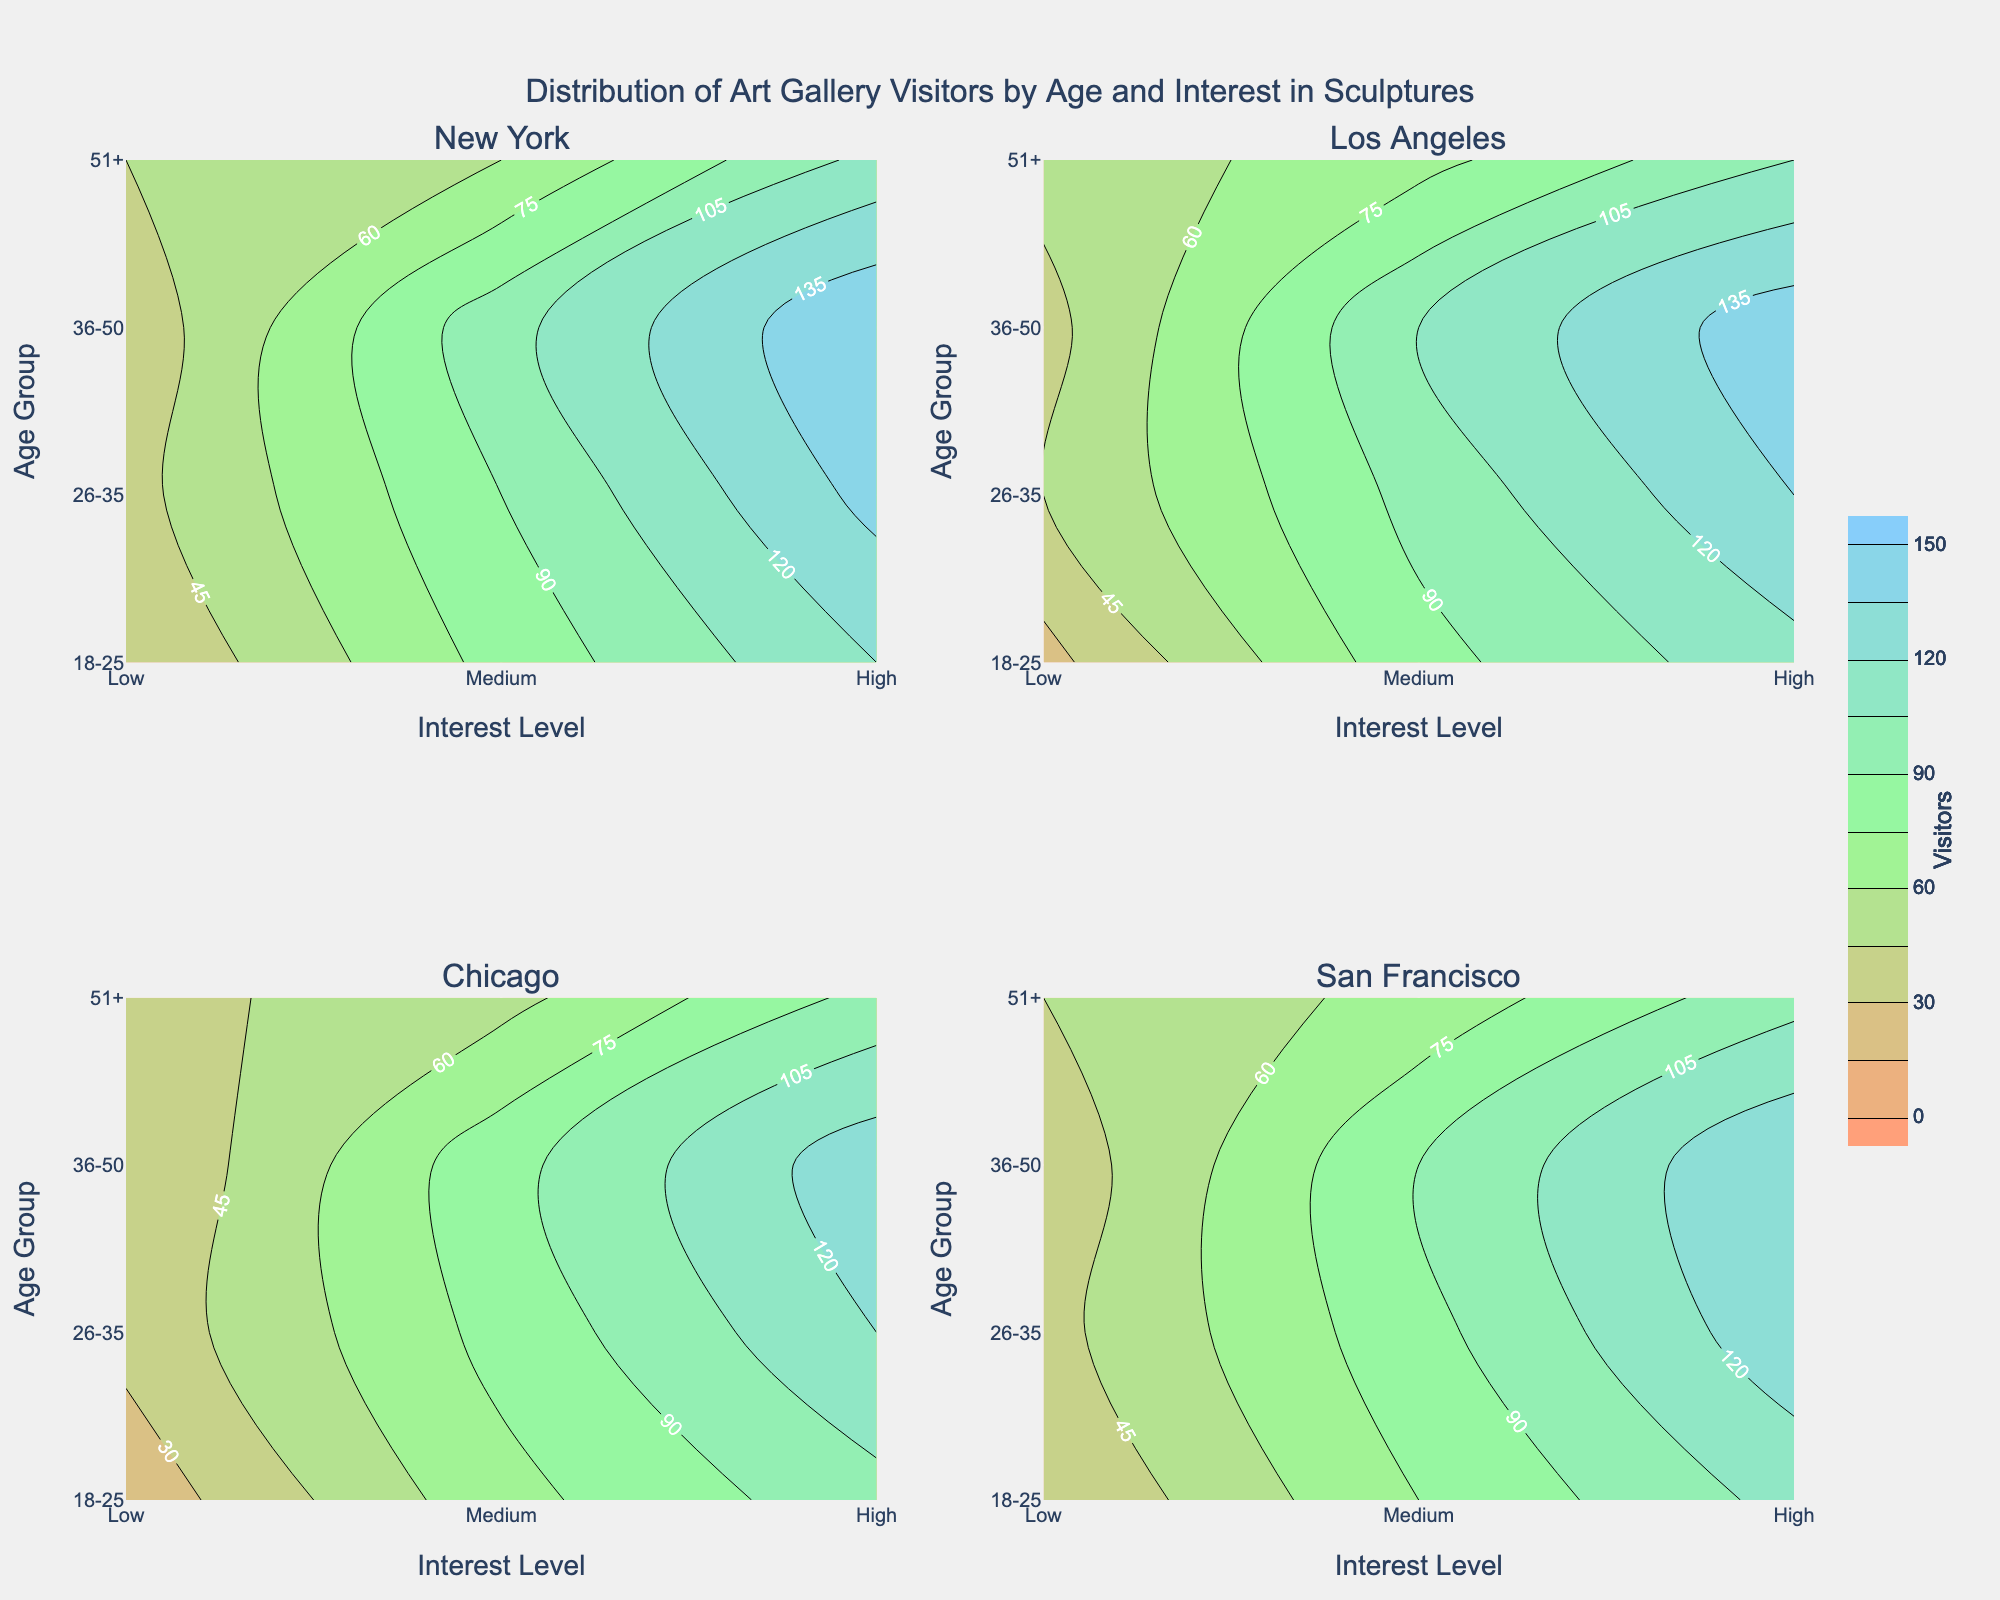Which age group in New York has the highest number of visitors with a high interest in sculptures? The contour plot for New York shows that the 36-50 age group has the highest number of visitors with a high interest level. The contour is at its highest peak in this age and interest group, marking 150 visitors.
Answer: 36-50 Which city has the lowest number of visitors with low interest in the 18-25 age group? The contour plot for Chicago shows the lowest number of visitors in the 18-25 age group with low interest in sculptures at 20 visitors, which is lower compared to other cities.
Answer: Chicago Compare the number of visitors aged 26-35 with a high interest in sculptures between New York and Los Angeles. Which city has more visitors? In New York, the contour plot indicates 140 visitors in the 26-35 age group with high interest, while Los Angeles shows 135 visitors in the same category. Therefore, New York has more visitors.
Answer: New York What is the general trend in the number of visitors with medium interest in sculptures across different age groups in San Francisco? The contour plot for San Francisco indicates an increasing trend in the number of visitors with medium interest in sculptures as age increases. For example, the visitor count starts from 75 in the 18-25 age group and increases to 90 in the 36-50 age group before decreasing slightly to 65 in the 51+ age group.
Answer: Increase then slight decrease with age In which city do visitors aged 51+ with a medium interest in sculptures have the highest count? Comparing the contour plots of all the cities, Los Angeles shows the highest number of visitors in the 51+ age group with a medium interest in sculptures at 70 visitors.
Answer: Los Angeles Find the age group in Chicago with the smallest difference in visitor numbers between medium and high interest levels. For the 36-50 age group in Chicago, the contour plot shows 85 visitors with medium interest and 130 visitors with high interest, giving a difference of 45, which is smaller compared to other age groups.
Answer: 36-50 Describe how the contour plot for visitors with high interest in sculptures compares between New York and San Francisco for the 36-50 age group. In both New York and San Francisco, the contour plot peaks for the 36-50 age group with a high interest in sculptures, showing New York with 150 visitors and San Francisco with 135 visitors. Thus, New York has a higher peak than San Francisco.
Answer: New York has a higher peak What is the most common contour level (range of visitors) across all cities and age groups for visitors with high interest in sculptures? Observing the contour plots across all cities, the most common contour level for high interest in sculptures ranges typically between 100 to 150 visitors. This level is the most frequently observed across various age groups and cities.
Answer: 100-150 